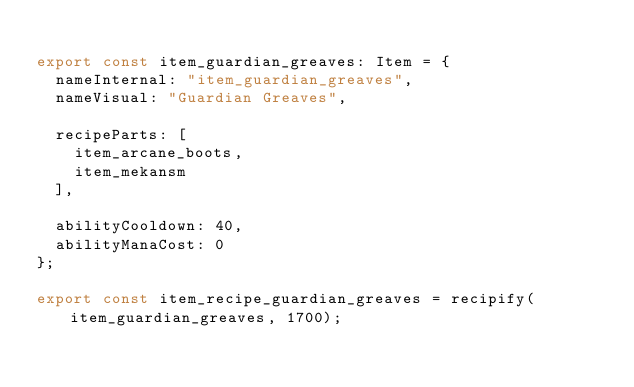<code> <loc_0><loc_0><loc_500><loc_500><_TypeScript_>
export const item_guardian_greaves: Item = {
	nameInternal: "item_guardian_greaves",
	nameVisual: "Guardian Greaves",

	recipeParts: [
		item_arcane_boots,
		item_mekansm
	],

	abilityCooldown: 40,
	abilityManaCost: 0
};

export const item_recipe_guardian_greaves = recipify(item_guardian_greaves, 1700);
</code> 